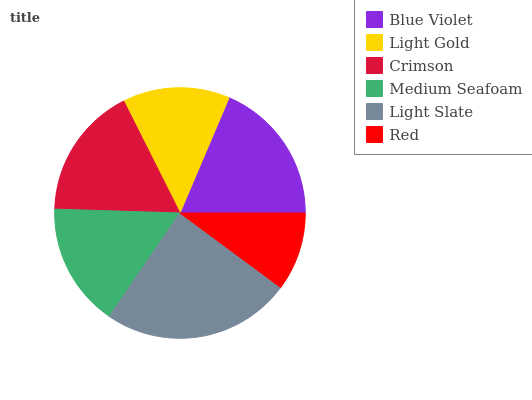Is Red the minimum?
Answer yes or no. Yes. Is Light Slate the maximum?
Answer yes or no. Yes. Is Light Gold the minimum?
Answer yes or no. No. Is Light Gold the maximum?
Answer yes or no. No. Is Blue Violet greater than Light Gold?
Answer yes or no. Yes. Is Light Gold less than Blue Violet?
Answer yes or no. Yes. Is Light Gold greater than Blue Violet?
Answer yes or no. No. Is Blue Violet less than Light Gold?
Answer yes or no. No. Is Crimson the high median?
Answer yes or no. Yes. Is Medium Seafoam the low median?
Answer yes or no. Yes. Is Light Slate the high median?
Answer yes or no. No. Is Blue Violet the low median?
Answer yes or no. No. 